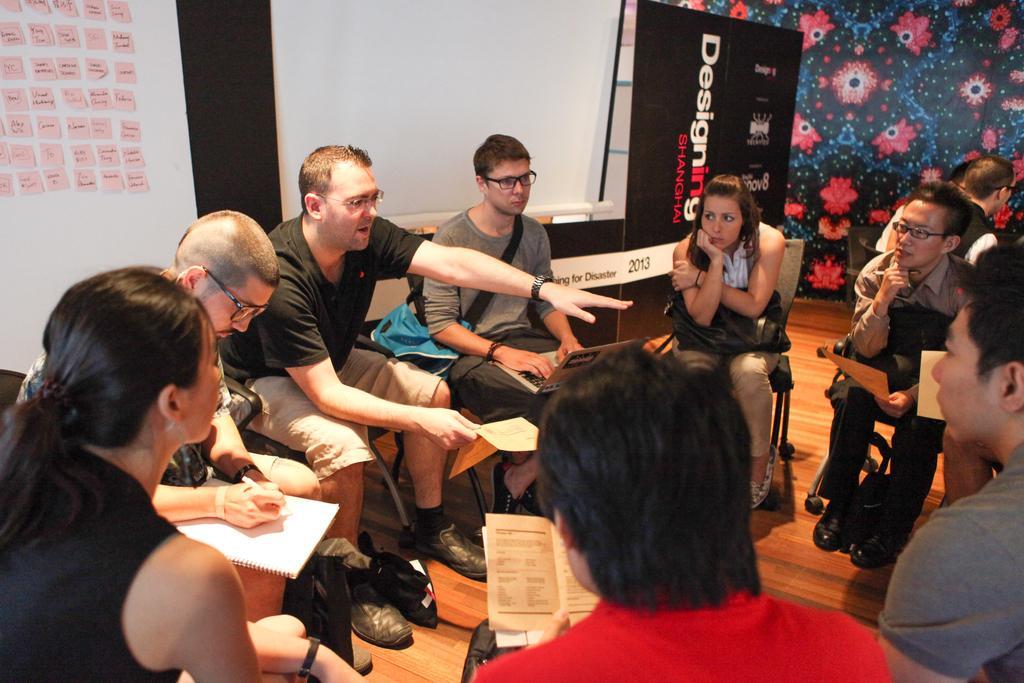Could you give a brief overview of what you see in this image? In the center of the image a group of people sitting on a chair, some of them are holding books in there hand. In the background of the image we can see boards, wall. At the bottom of the image there is a floor. 